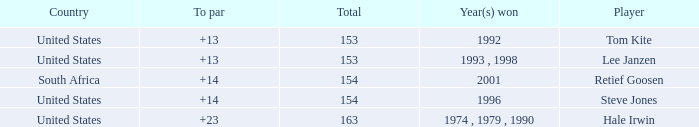What is the total that South Africa had a par greater than 14 None. 